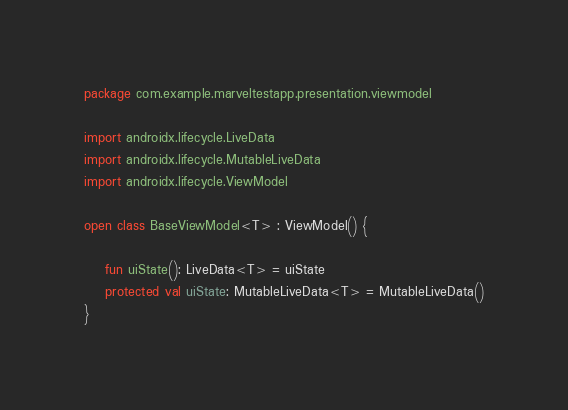<code> <loc_0><loc_0><loc_500><loc_500><_Kotlin_>package com.example.marveltestapp.presentation.viewmodel

import androidx.lifecycle.LiveData
import androidx.lifecycle.MutableLiveData
import androidx.lifecycle.ViewModel

open class BaseViewModel<T> : ViewModel() {

    fun uiState(): LiveData<T> = uiState
    protected val uiState: MutableLiveData<T> = MutableLiveData()
}</code> 